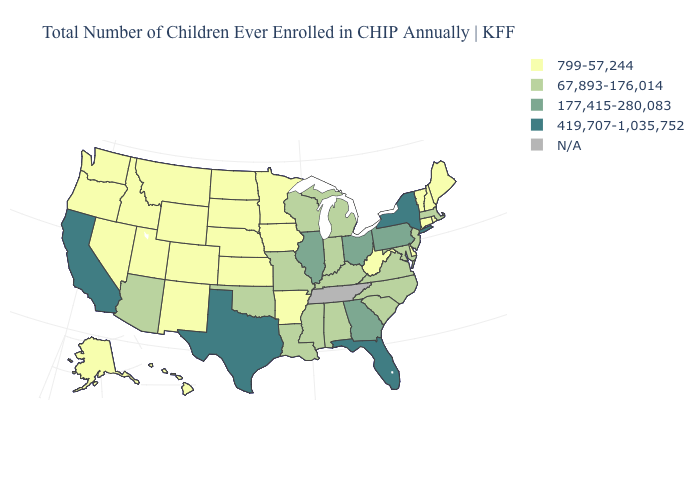What is the value of Connecticut?
Concise answer only. 799-57,244. What is the value of Massachusetts?
Keep it brief. 67,893-176,014. What is the lowest value in the South?
Answer briefly. 799-57,244. Name the states that have a value in the range 799-57,244?
Answer briefly. Alaska, Arkansas, Colorado, Connecticut, Delaware, Hawaii, Idaho, Iowa, Kansas, Maine, Minnesota, Montana, Nebraska, Nevada, New Hampshire, New Mexico, North Dakota, Oregon, Rhode Island, South Dakota, Utah, Vermont, Washington, West Virginia, Wyoming. Name the states that have a value in the range 177,415-280,083?
Write a very short answer. Georgia, Illinois, Ohio, Pennsylvania. What is the value of Washington?
Keep it brief. 799-57,244. Among the states that border Massachusetts , which have the highest value?
Keep it brief. New York. Name the states that have a value in the range 67,893-176,014?
Be succinct. Alabama, Arizona, Indiana, Kentucky, Louisiana, Maryland, Massachusetts, Michigan, Mississippi, Missouri, New Jersey, North Carolina, Oklahoma, South Carolina, Virginia, Wisconsin. What is the value of Iowa?
Quick response, please. 799-57,244. Name the states that have a value in the range N/A?
Be succinct. Tennessee. What is the value of Delaware?
Quick response, please. 799-57,244. What is the highest value in the USA?
Write a very short answer. 419,707-1,035,752. What is the lowest value in the USA?
Write a very short answer. 799-57,244. 